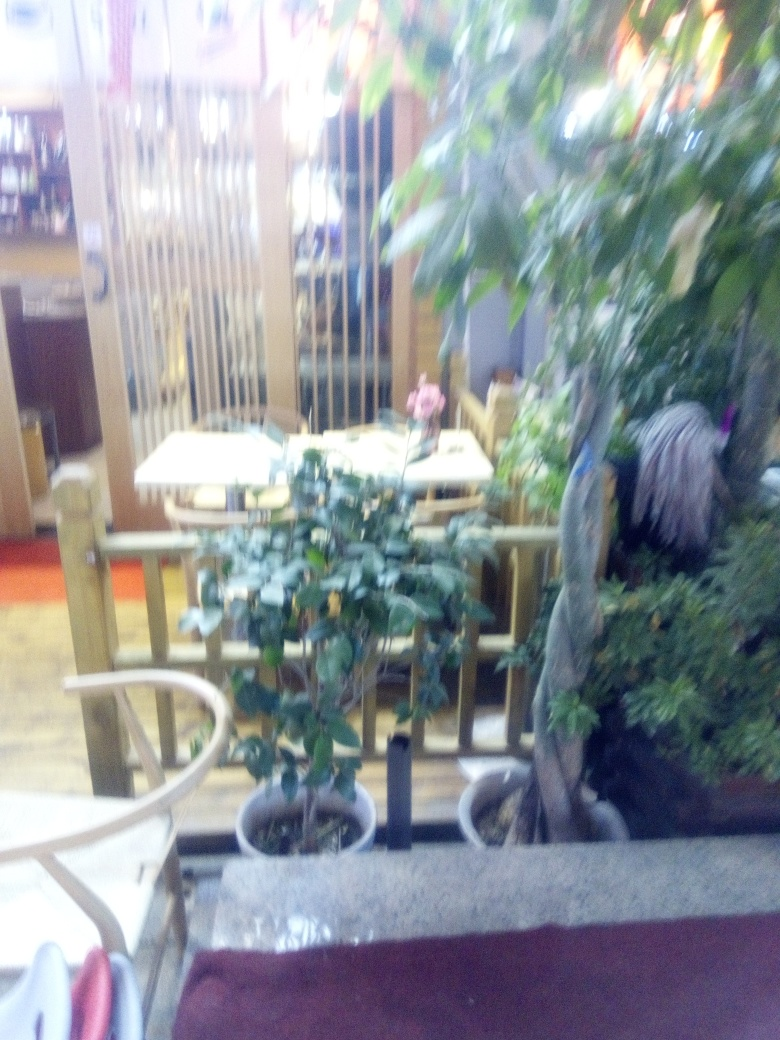Is the image sharp? The image is not sharp; it is blurry, affecting the clarity of details such as the individual leaves on the plants and the textures on the furniture. 